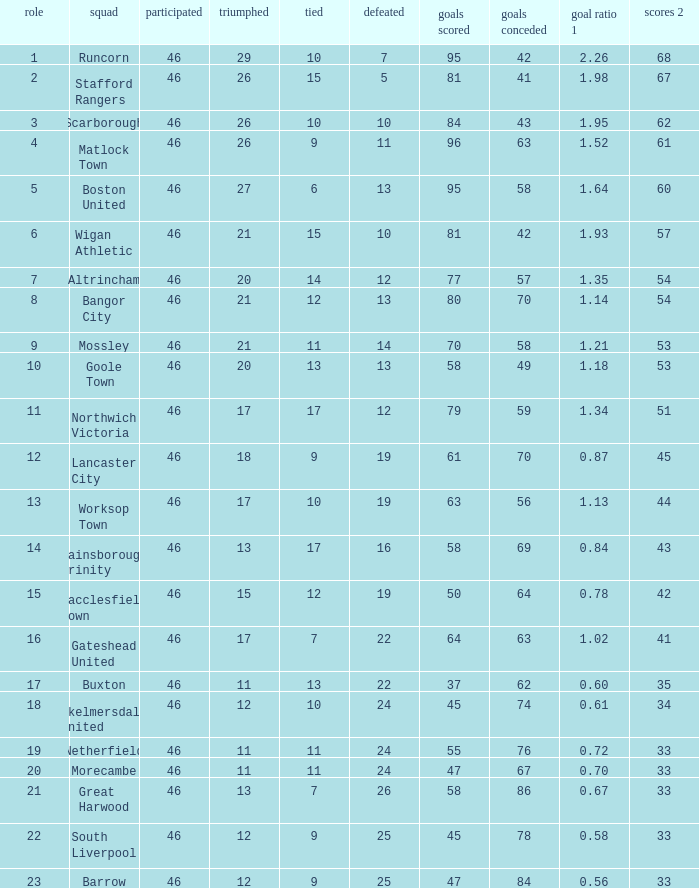I'm looking to parse the entire table for insights. Could you assist me with that? {'header': ['role', 'squad', 'participated', 'triumphed', 'tied', 'defeated', 'goals scored', 'goals conceded', 'goal ratio 1', 'scores 2'], 'rows': [['1', 'Runcorn', '46', '29', '10', '7', '95', '42', '2.26', '68'], ['2', 'Stafford Rangers', '46', '26', '15', '5', '81', '41', '1.98', '67'], ['3', 'Scarborough', '46', '26', '10', '10', '84', '43', '1.95', '62'], ['4', 'Matlock Town', '46', '26', '9', '11', '96', '63', '1.52', '61'], ['5', 'Boston United', '46', '27', '6', '13', '95', '58', '1.64', '60'], ['6', 'Wigan Athletic', '46', '21', '15', '10', '81', '42', '1.93', '57'], ['7', 'Altrincham', '46', '20', '14', '12', '77', '57', '1.35', '54'], ['8', 'Bangor City', '46', '21', '12', '13', '80', '70', '1.14', '54'], ['9', 'Mossley', '46', '21', '11', '14', '70', '58', '1.21', '53'], ['10', 'Goole Town', '46', '20', '13', '13', '58', '49', '1.18', '53'], ['11', 'Northwich Victoria', '46', '17', '17', '12', '79', '59', '1.34', '51'], ['12', 'Lancaster City', '46', '18', '9', '19', '61', '70', '0.87', '45'], ['13', 'Worksop Town', '46', '17', '10', '19', '63', '56', '1.13', '44'], ['14', 'Gainsborough Trinity', '46', '13', '17', '16', '58', '69', '0.84', '43'], ['15', 'Macclesfield Town', '46', '15', '12', '19', '50', '64', '0.78', '42'], ['16', 'Gateshead United', '46', '17', '7', '22', '64', '63', '1.02', '41'], ['17', 'Buxton', '46', '11', '13', '22', '37', '62', '0.60', '35'], ['18', 'Skelmersdale United', '46', '12', '10', '24', '45', '74', '0.61', '34'], ['19', 'Netherfield', '46', '11', '11', '24', '55', '76', '0.72', '33'], ['20', 'Morecambe', '46', '11', '11', '24', '47', '67', '0.70', '33'], ['21', 'Great Harwood', '46', '13', '7', '26', '58', '86', '0.67', '33'], ['22', 'South Liverpool', '46', '12', '9', '25', '45', '78', '0.58', '33'], ['23', 'Barrow', '46', '12', '9', '25', '47', '84', '0.56', '33']]} Which team had goal averages of 1.34? Northwich Victoria. 